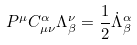<formula> <loc_0><loc_0><loc_500><loc_500>P ^ { \mu } C ^ { \alpha } _ { \mu \nu } \Lambda ^ { \nu } _ { \beta } = \frac { 1 } { 2 } \dot { \Lambda } ^ { \alpha } _ { \beta }</formula> 